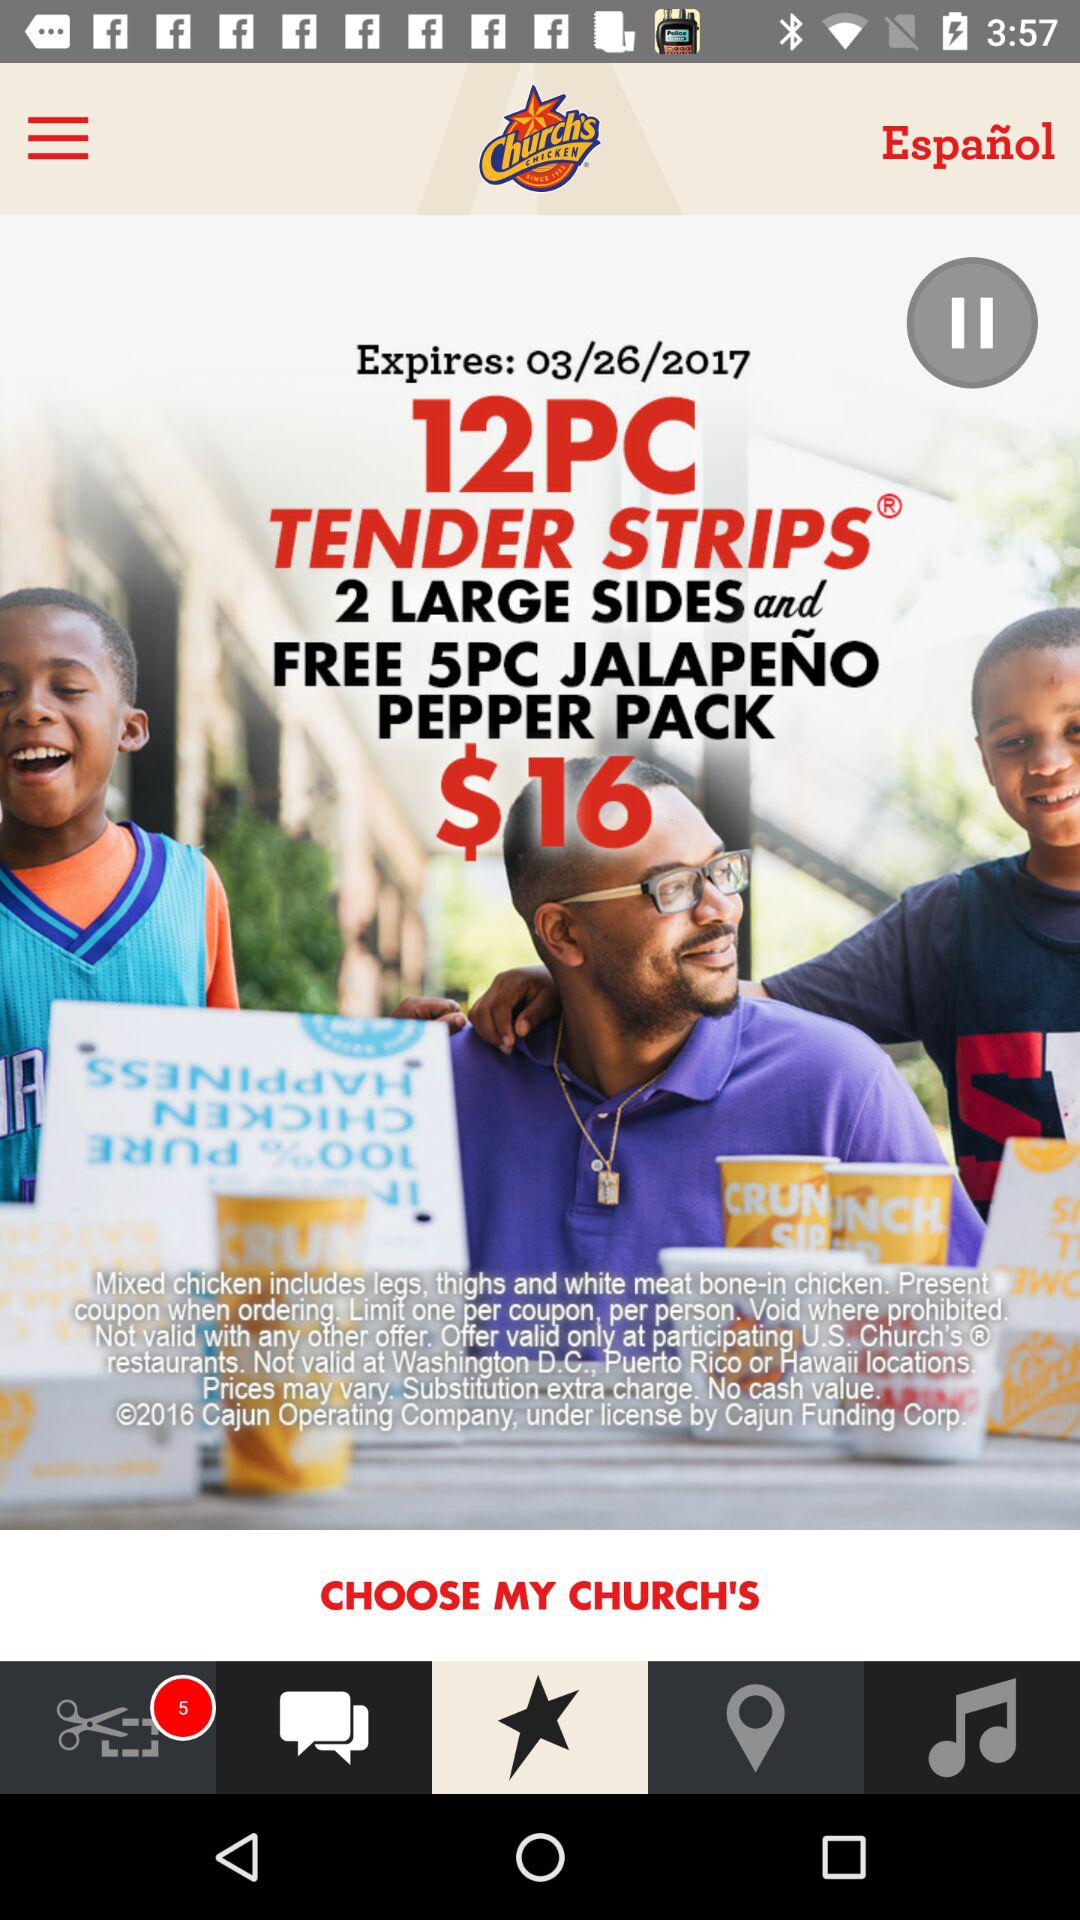How many sides are included in the coupon?
Answer the question using a single word or phrase. 2 